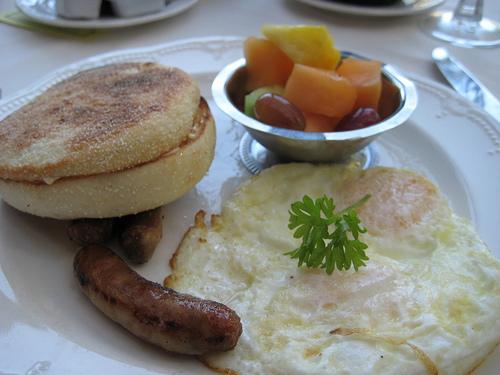What kind of fruit is in the photo?
Give a very brief answer. Grapes, melons and pineapple. Is the fruit ripe?
Give a very brief answer. Yes. Is there a vegetable in this picture?
Give a very brief answer. No. What fruit is in the back?
Keep it brief. Melon, pineapple, grape. How many eggs have been fired?
Answer briefly. 2. How many grapes do you see?
Keep it brief. 2. Is this a healthy meal?
Answer briefly. Yes. What is on the plate?
Concise answer only. Breakfast. What are green?
Concise answer only. Parsley. What kind of seeds are on the crust of the bread?
Be succinct. None. How many sausages are on the plate?
Quick response, please. 2. What is garnishing the plate?
Concise answer only. Parsley. 